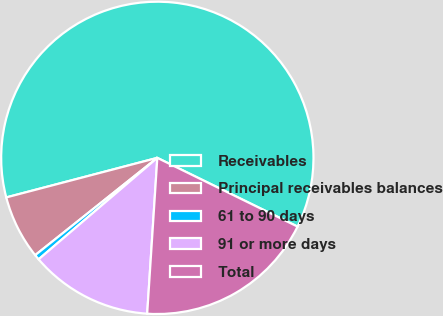Convert chart to OTSL. <chart><loc_0><loc_0><loc_500><loc_500><pie_chart><fcel>Receivables<fcel>Principal receivables balances<fcel>61 to 90 days<fcel>91 or more days<fcel>Total<nl><fcel>61.33%<fcel>6.63%<fcel>0.55%<fcel>12.71%<fcel>18.78%<nl></chart> 